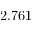<formula> <loc_0><loc_0><loc_500><loc_500>2 . 7 6 1</formula> 